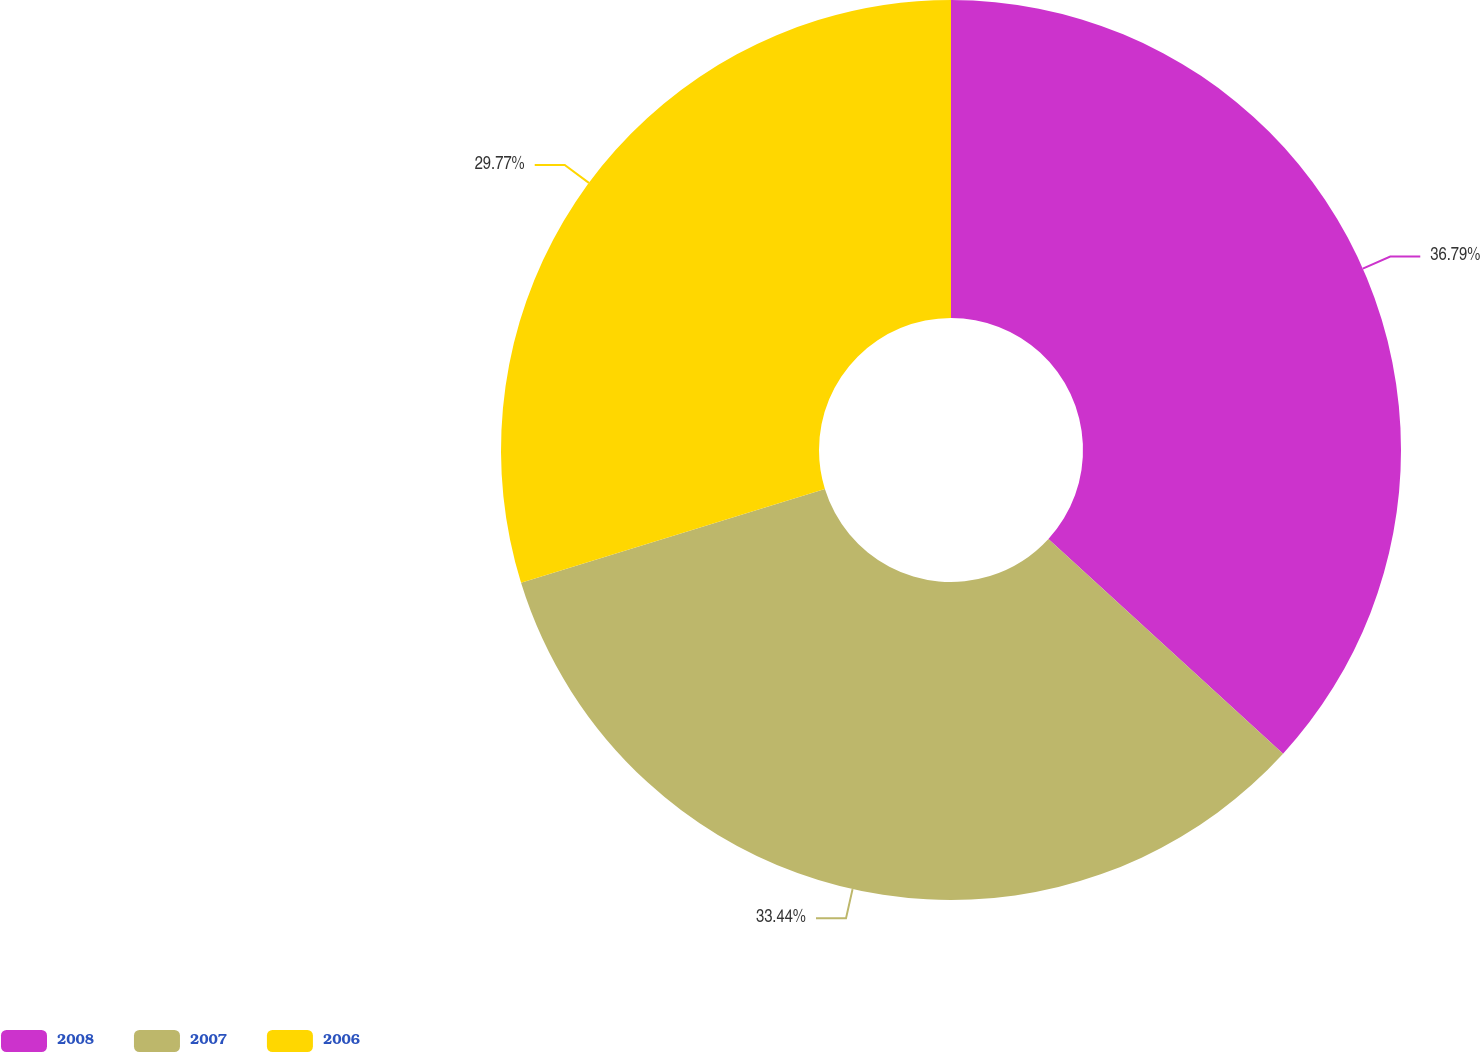Convert chart to OTSL. <chart><loc_0><loc_0><loc_500><loc_500><pie_chart><fcel>2008<fcel>2007<fcel>2006<nl><fcel>36.79%<fcel>33.44%<fcel>29.77%<nl></chart> 